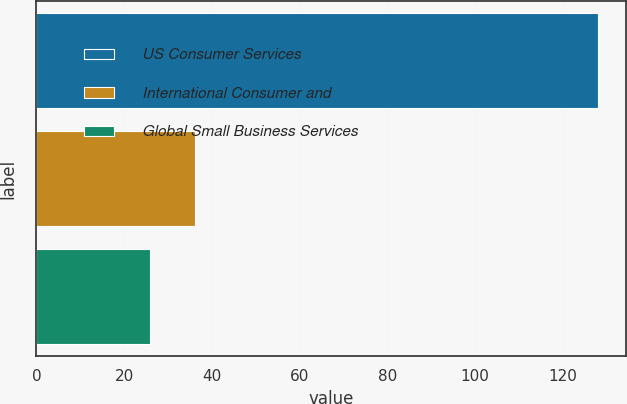<chart> <loc_0><loc_0><loc_500><loc_500><bar_chart><fcel>US Consumer Services<fcel>International Consumer and<fcel>Global Small Business Services<nl><fcel>128<fcel>36.2<fcel>26<nl></chart> 